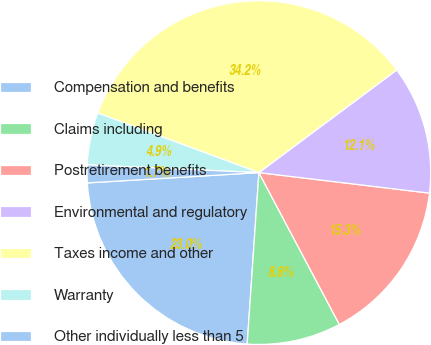Convert chart to OTSL. <chart><loc_0><loc_0><loc_500><loc_500><pie_chart><fcel>Compensation and benefits<fcel>Claims including<fcel>Postretirement benefits<fcel>Environmental and regulatory<fcel>Taxes income and other<fcel>Warranty<fcel>Other individually less than 5<nl><fcel>22.96%<fcel>8.84%<fcel>15.34%<fcel>12.09%<fcel>34.18%<fcel>4.92%<fcel>1.67%<nl></chart> 